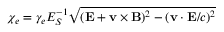<formula> <loc_0><loc_0><loc_500><loc_500>\chi _ { e } = \gamma _ { e } E _ { S } ^ { - 1 } \sqrt { ( { E } + { v } \times { B } ) ^ { 2 } - ( { v } \cdot { E } / c ) ^ { 2 } }</formula> 